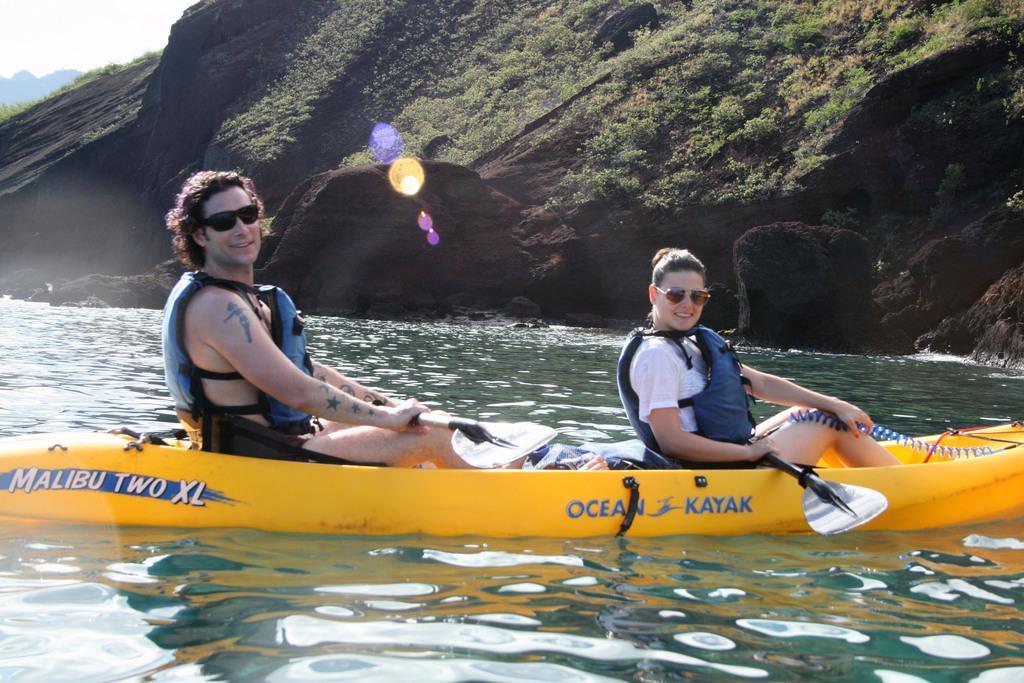Describe this image in one or two sentences. In this picture there is a man who is wearing jacket, short and goggles, beside him there is a woman. She is wearing goggle, t-shirt, jacket and short. Both of them are sitting on the yellow boat bottom. At the bottom i can see the water. In the background i can see plants, grass and mountain. In the top left corner there is a sky. 